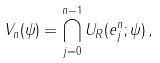<formula> <loc_0><loc_0><loc_500><loc_500>V _ { n } ( \psi ) = \bigcap _ { j = 0 } ^ { n - 1 } U _ { R } ( e ^ { n } _ { j } ; \psi ) \, ,</formula> 